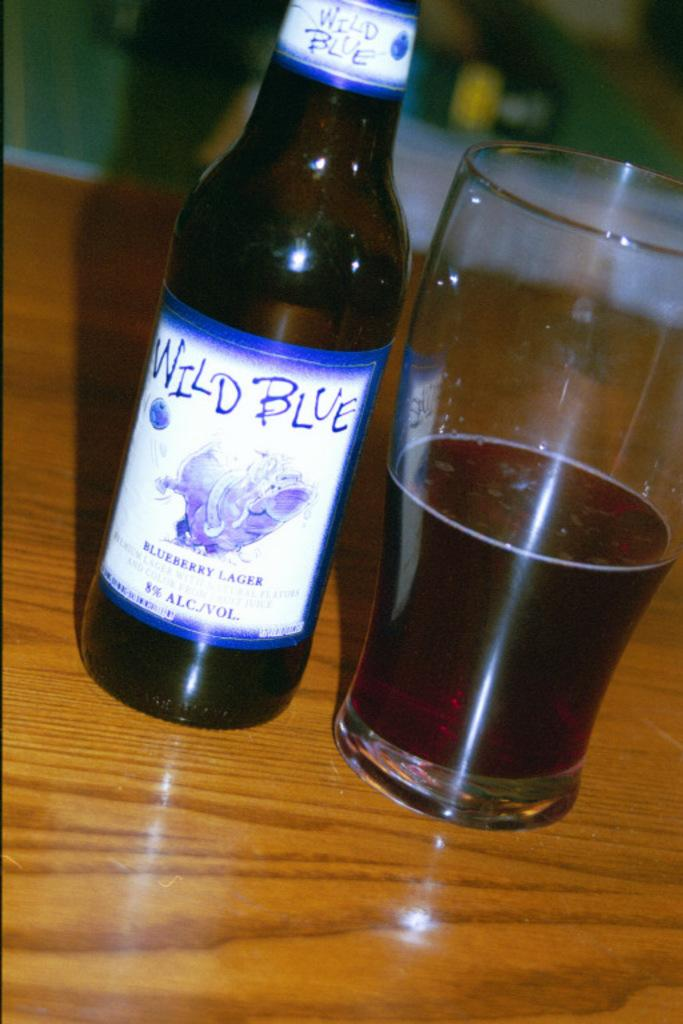<image>
Render a clear and concise summary of the photo. a bottle of wild blue blueberry lager standing next to a glass full of it 